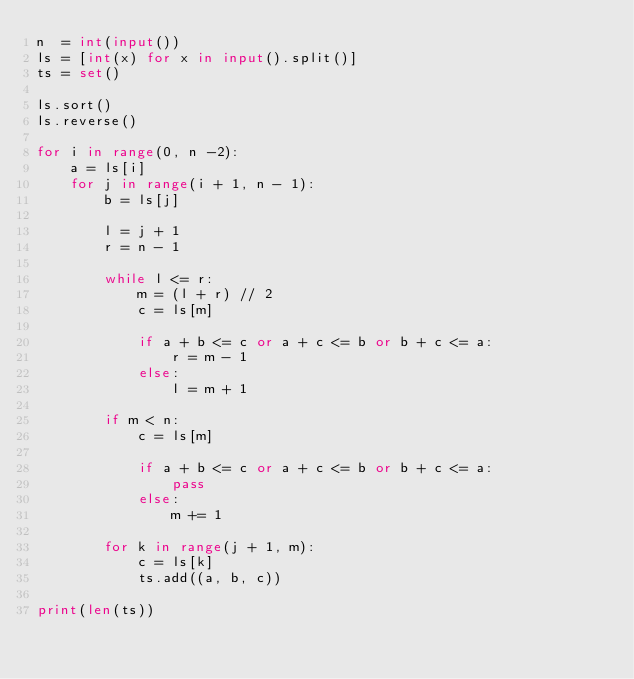<code> <loc_0><loc_0><loc_500><loc_500><_Python_>n  = int(input())
ls = [int(x) for x in input().split()]
ts = set()

ls.sort()
ls.reverse()
 
for i in range(0, n -2):
	a = ls[i]
	for j in range(i + 1, n - 1):
		b = ls[j]
		
		l = j + 1
		r = n - 1
		
		while l <= r:
			m = (l + r) // 2
			c = ls[m]
		
			if a + b <= c or a + c <= b or b + c <= a:
				r = m - 1
			else:
				l = m + 1
		
		if m < n:
			c = ls[m]
			
			if a + b <= c or a + c <= b or b + c <= a:
				pass
			else:
				m += 1
		
		for k in range(j + 1, m):
			c = ls[k]
			ts.add((a, b, c))
		
print(len(ts))</code> 